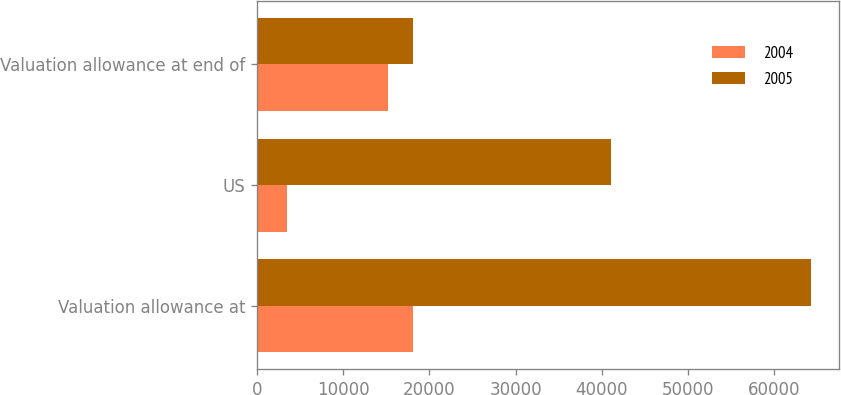Convert chart. <chart><loc_0><loc_0><loc_500><loc_500><stacked_bar_chart><ecel><fcel>Valuation allowance at<fcel>US<fcel>Valuation allowance at end of<nl><fcel>2004<fcel>18136<fcel>3419<fcel>15218<nl><fcel>2005<fcel>64252<fcel>41095<fcel>18136<nl></chart> 